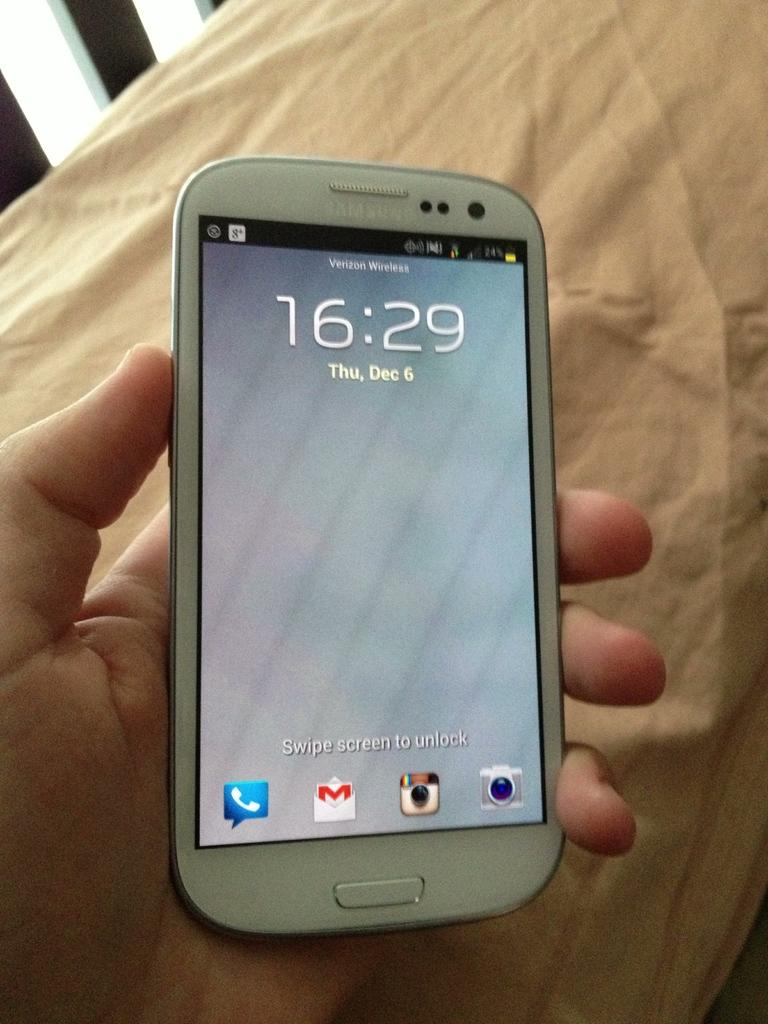<image>
Give a short and clear explanation of the subsequent image. a phone that has the time of 16:29 on it 